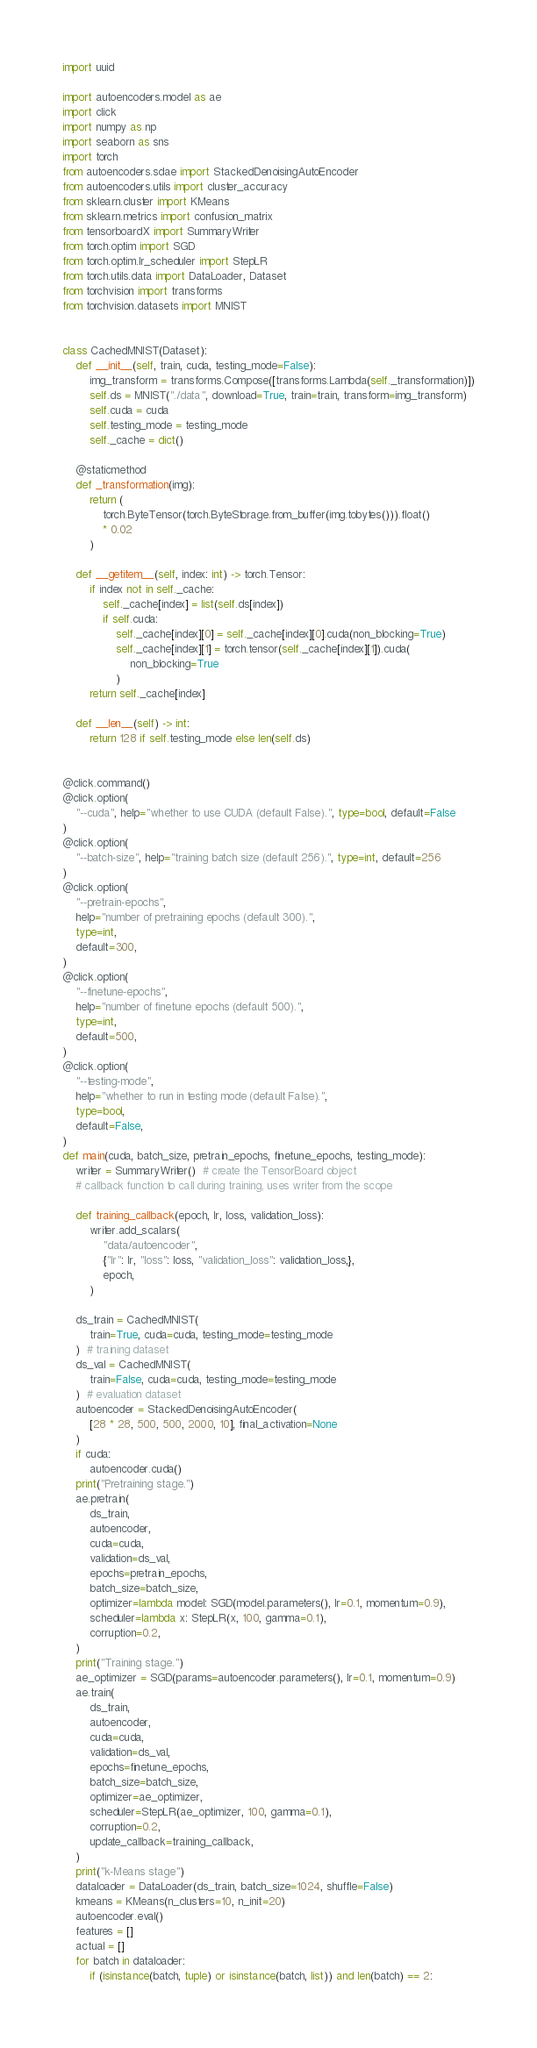Convert code to text. <code><loc_0><loc_0><loc_500><loc_500><_Python_>import uuid

import autoencoders.model as ae
import click
import numpy as np
import seaborn as sns
import torch
from autoencoders.sdae import StackedDenoisingAutoEncoder
from autoencoders.utils import cluster_accuracy
from sklearn.cluster import KMeans
from sklearn.metrics import confusion_matrix
from tensorboardX import SummaryWriter
from torch.optim import SGD
from torch.optim.lr_scheduler import StepLR
from torch.utils.data import DataLoader, Dataset
from torchvision import transforms
from torchvision.datasets import MNIST


class CachedMNIST(Dataset):
    def __init__(self, train, cuda, testing_mode=False):
        img_transform = transforms.Compose([transforms.Lambda(self._transformation)])
        self.ds = MNIST("./data", download=True, train=train, transform=img_transform)
        self.cuda = cuda
        self.testing_mode = testing_mode
        self._cache = dict()

    @staticmethod
    def _transformation(img):
        return (
            torch.ByteTensor(torch.ByteStorage.from_buffer(img.tobytes())).float()
            * 0.02
        )

    def __getitem__(self, index: int) -> torch.Tensor:
        if index not in self._cache:
            self._cache[index] = list(self.ds[index])
            if self.cuda:
                self._cache[index][0] = self._cache[index][0].cuda(non_blocking=True)
                self._cache[index][1] = torch.tensor(self._cache[index][1]).cuda(
                    non_blocking=True
                )
        return self._cache[index]

    def __len__(self) -> int:
        return 128 if self.testing_mode else len(self.ds)


@click.command()
@click.option(
    "--cuda", help="whether to use CUDA (default False).", type=bool, default=False
)
@click.option(
    "--batch-size", help="training batch size (default 256).", type=int, default=256
)
@click.option(
    "--pretrain-epochs",
    help="number of pretraining epochs (default 300).",
    type=int,
    default=300,
)
@click.option(
    "--finetune-epochs",
    help="number of finetune epochs (default 500).",
    type=int,
    default=500,
)
@click.option(
    "--testing-mode",
    help="whether to run in testing mode (default False).",
    type=bool,
    default=False,
)
def main(cuda, batch_size, pretrain_epochs, finetune_epochs, testing_mode):
    writer = SummaryWriter()  # create the TensorBoard object
    # callback function to call during training, uses writer from the scope

    def training_callback(epoch, lr, loss, validation_loss):
        writer.add_scalars(
            "data/autoencoder",
            {"lr": lr, "loss": loss, "validation_loss": validation_loss,},
            epoch,
        )

    ds_train = CachedMNIST(
        train=True, cuda=cuda, testing_mode=testing_mode
    )  # training dataset
    ds_val = CachedMNIST(
        train=False, cuda=cuda, testing_mode=testing_mode
    )  # evaluation dataset
    autoencoder = StackedDenoisingAutoEncoder(
        [28 * 28, 500, 500, 2000, 10], final_activation=None
    )
    if cuda:
        autoencoder.cuda()
    print("Pretraining stage.")
    ae.pretrain(
        ds_train,
        autoencoder,
        cuda=cuda,
        validation=ds_val,
        epochs=pretrain_epochs,
        batch_size=batch_size,
        optimizer=lambda model: SGD(model.parameters(), lr=0.1, momentum=0.9),
        scheduler=lambda x: StepLR(x, 100, gamma=0.1),
        corruption=0.2,
    )
    print("Training stage.")
    ae_optimizer = SGD(params=autoencoder.parameters(), lr=0.1, momentum=0.9)
    ae.train(
        ds_train,
        autoencoder,
        cuda=cuda,
        validation=ds_val,
        epochs=finetune_epochs,
        batch_size=batch_size,
        optimizer=ae_optimizer,
        scheduler=StepLR(ae_optimizer, 100, gamma=0.1),
        corruption=0.2,
        update_callback=training_callback,
    )
    print("k-Means stage")
    dataloader = DataLoader(ds_train, batch_size=1024, shuffle=False)
    kmeans = KMeans(n_clusters=10, n_init=20)
    autoencoder.eval()
    features = []
    actual = []
    for batch in dataloader:
        if (isinstance(batch, tuple) or isinstance(batch, list)) and len(batch) == 2:</code> 